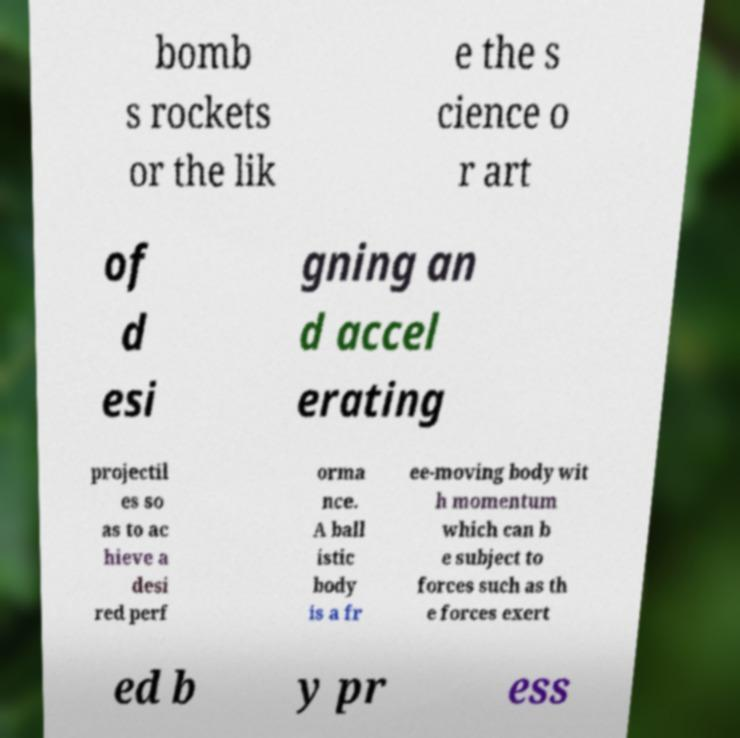Could you extract and type out the text from this image? bomb s rockets or the lik e the s cience o r art of d esi gning an d accel erating projectil es so as to ac hieve a desi red perf orma nce. A ball istic body is a fr ee-moving body wit h momentum which can b e subject to forces such as th e forces exert ed b y pr ess 